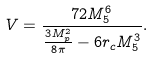<formula> <loc_0><loc_0><loc_500><loc_500>V = \frac { 7 2 M _ { 5 } ^ { 6 } } { \frac { 3 M _ { p } ^ { 2 } } { 8 \pi } - 6 r _ { c } M ^ { 3 } _ { 5 } } .</formula> 